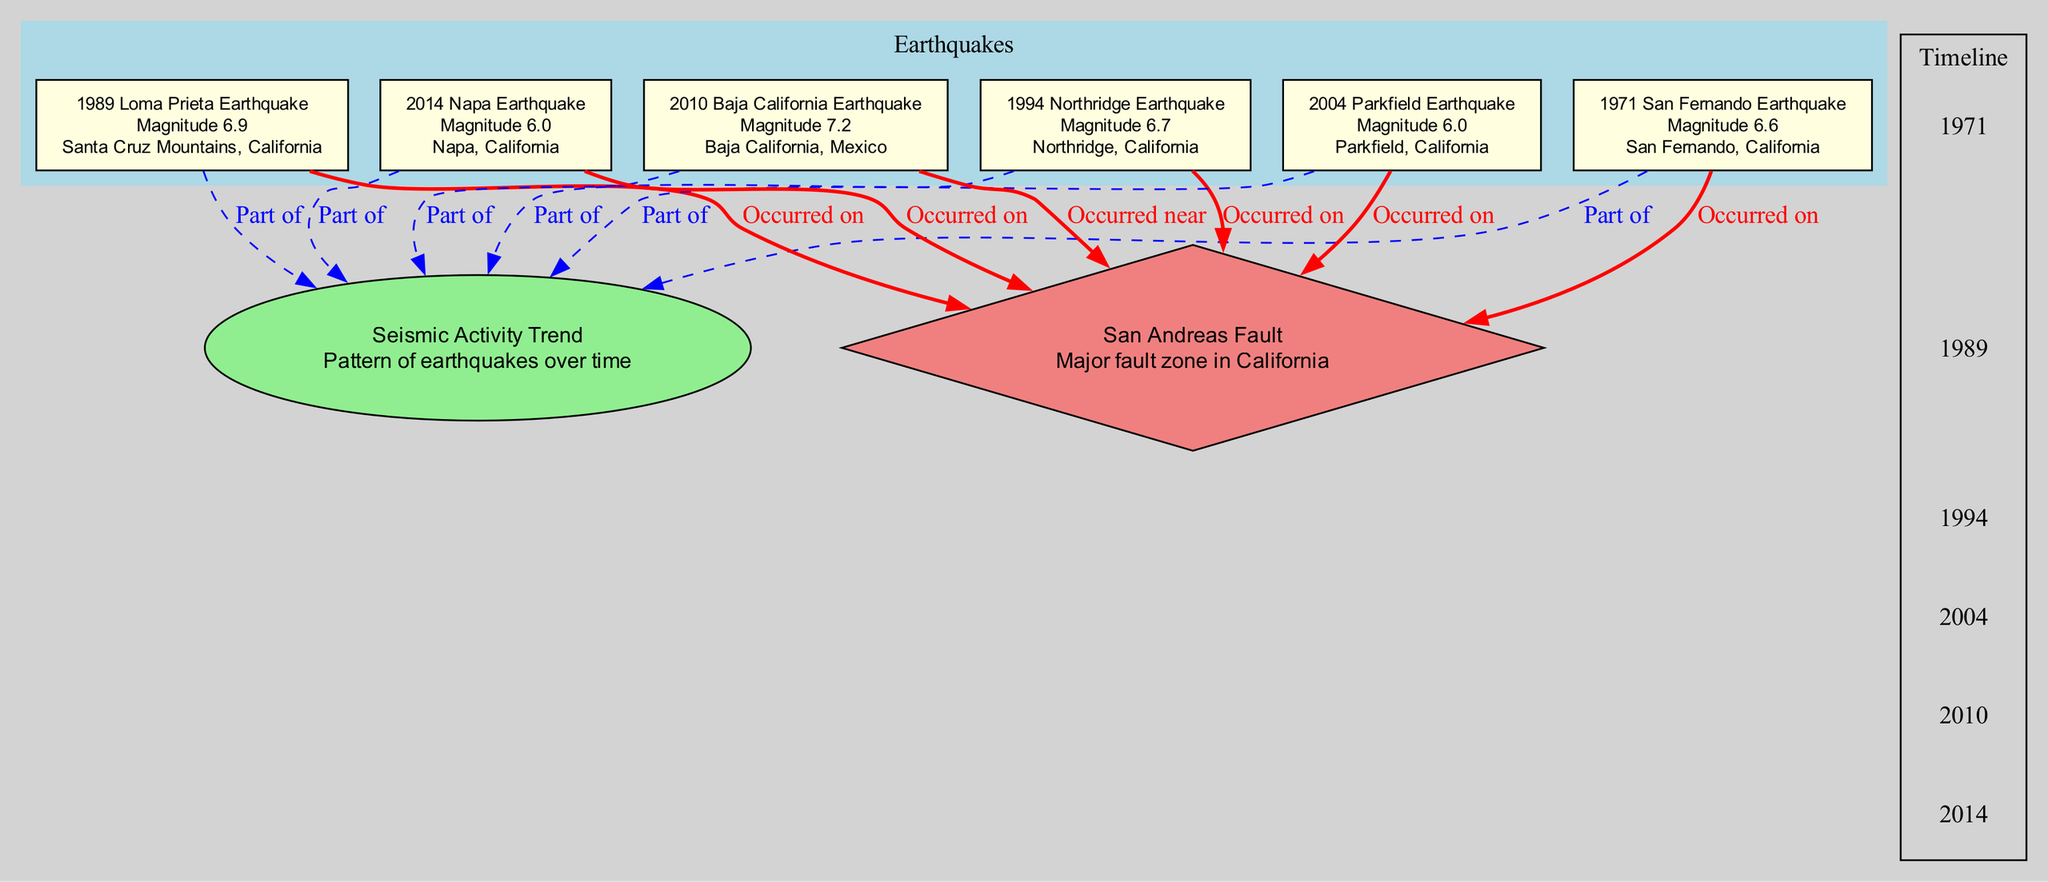What was the magnitude of the 1994 Northridge Earthquake? The diagram shows the description for the 1994 Northridge Earthquake, which states its magnitude is 6.7.
Answer: 6.7 Which earthquake occurred in the year 2010? In the diagram, the earthquake occurring in 2010 is labeled as the Baja California Earthquake.
Answer: Baja California Earthquake How many earthquakes occurred on the San Andreas Fault? By examining the edges connecting the earthquakes to the San Andreas Fault, we count a total of five direct connections indicating five earthquakes occurred on this fault.
Answer: 5 What is the relationship between the 1989 Loma Prieta Earthquake and the San Andreas Fault? The diagram illustrates a directed edge between the 1989 Loma Prieta Earthquake and the San Andreas Fault labeled "Occurred on,” indicating that this earthquake directly occurred on the fault.
Answer: Occurred on Which two earthquakes are part of the trend in seismic activity? The diagram shows that all six earthquakes, including the San Fernando (1971) and Napa (2014) events, are connected to the seismic activity trend indicating they are all part of it.
Answer: San Fernando Earthquake, Napa Earthquake What type of relationship exists between the 2010 Baja California Earthquake and the San Andreas Fault? The diagram specifies that the Baja California Earthquake is connected to the San Andreas Fault with the label "Occurred near,” indicating a proximity relationship rather than a direct occurrence.
Answer: Occurred near In which region did the 1971 San Fernando Earthquake occur? From the diagram, the node for the San Fernando Earthquake clearly labels its location as San Fernando, California.
Answer: San Fernando, California What year did the Parkfield Earthquake take place? The node for the Parkfield Earthquake in the diagram indicates it occurred in 2004, providing the specific year related to this seismic event.
Answer: 2004 